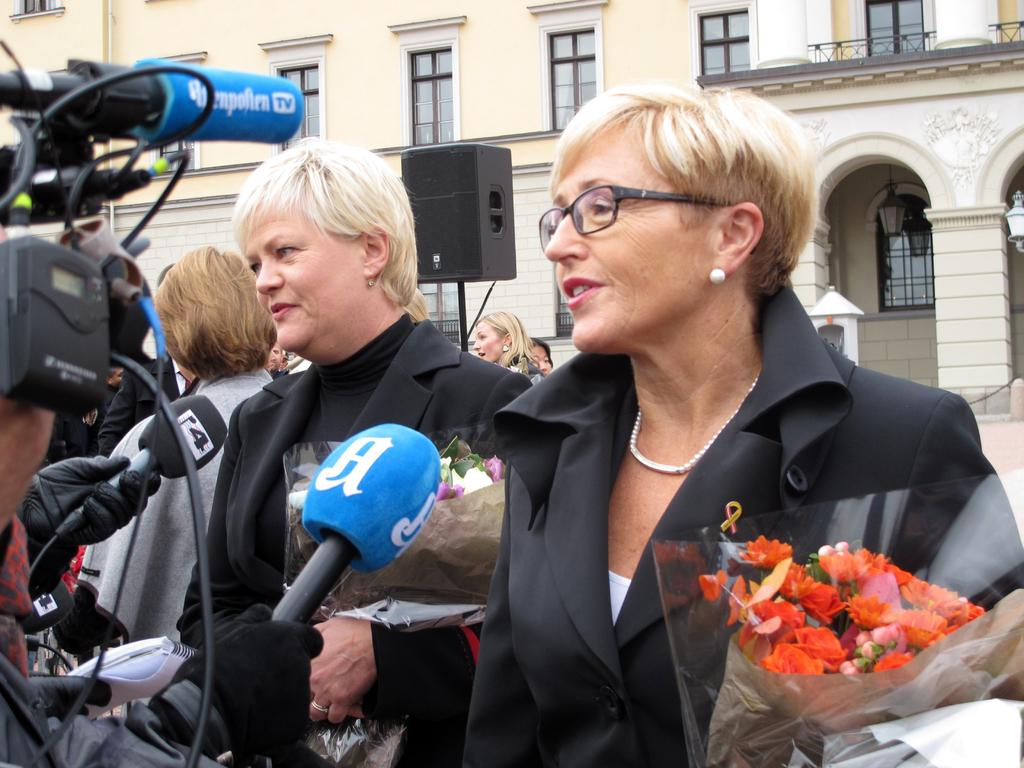How many women are present in the image? There are two women standing in the image. What are the women holding in their hands? The women are holding bouquets in their hands. What are the women doing in the image? The women are addressing the media. Can you describe the background of the image? There are a few other women visible in the background, along with a speaker and a building. What type of vessel is being used to transport apples in the image? There is no vessel or apples present in the image. What is the women's wish for the future, as seen in the image? The image does not provide any information about the women's wishes for the future. 